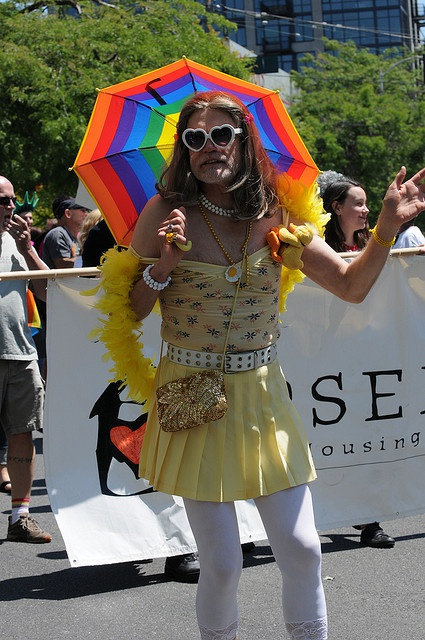Describe the objects in this image and their specific colors. I can see people in lightblue, gray, olive, black, and maroon tones, umbrella in lightblue, red, brown, and blue tones, people in lightblue, black, gray, darkgray, and lightgray tones, handbag in lightblue, olive, black, and gray tones, and people in lightblue, black, brown, and maroon tones in this image. 